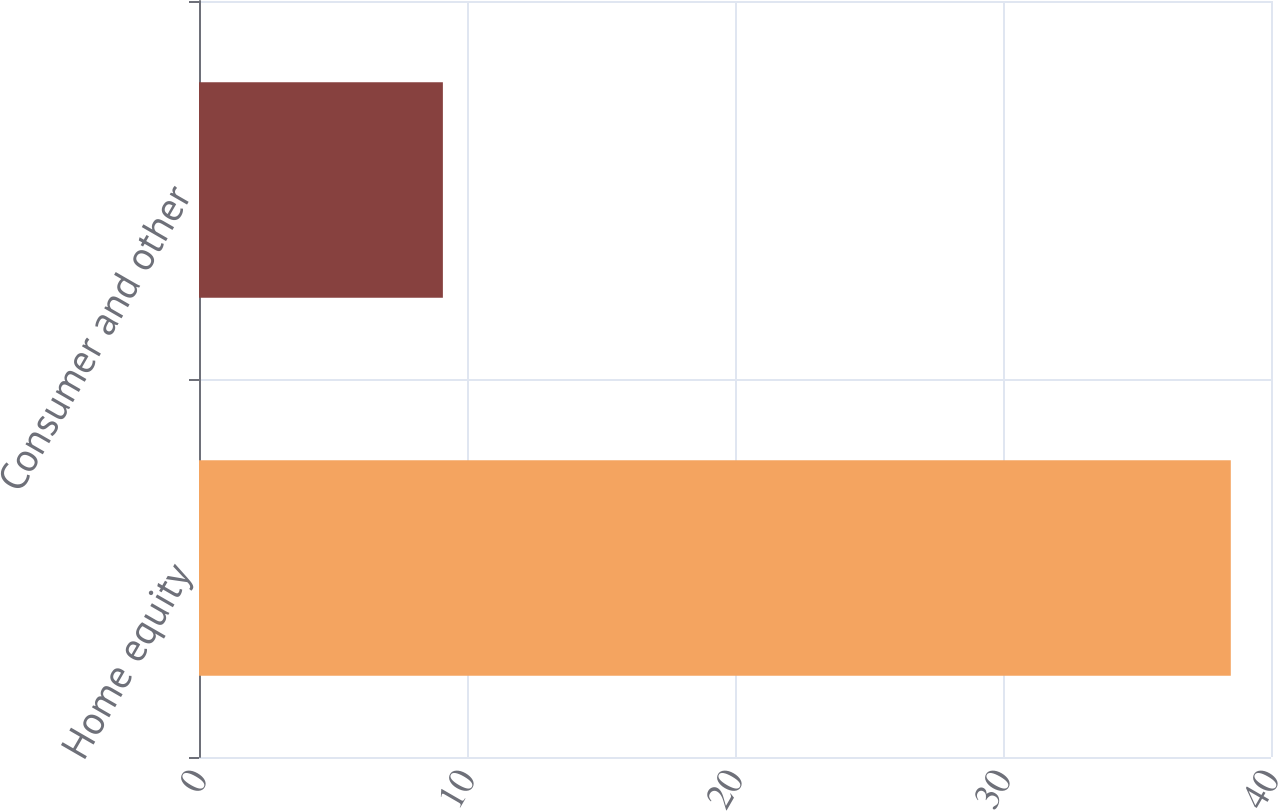<chart> <loc_0><loc_0><loc_500><loc_500><bar_chart><fcel>Home equity<fcel>Consumer and other<nl><fcel>38.5<fcel>9.1<nl></chart> 